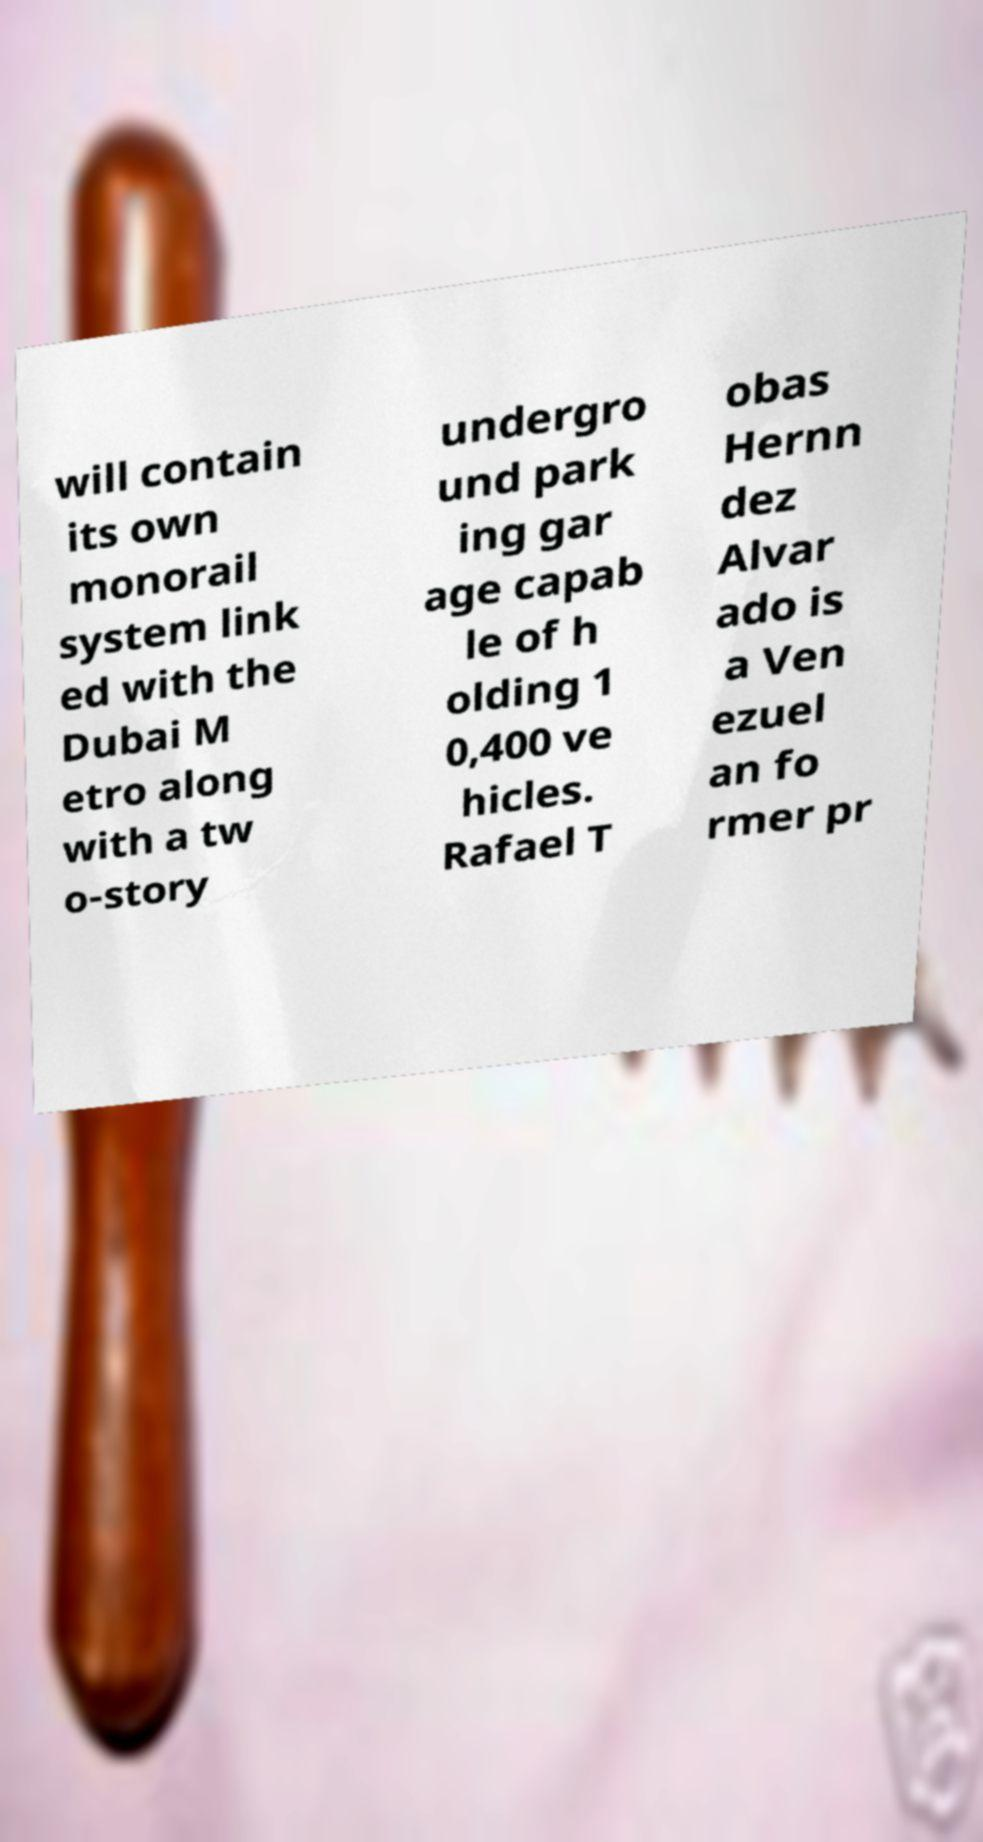For documentation purposes, I need the text within this image transcribed. Could you provide that? will contain its own monorail system link ed with the Dubai M etro along with a tw o-story undergro und park ing gar age capab le of h olding 1 0,400 ve hicles. Rafael T obas Hernn dez Alvar ado is a Ven ezuel an fo rmer pr 